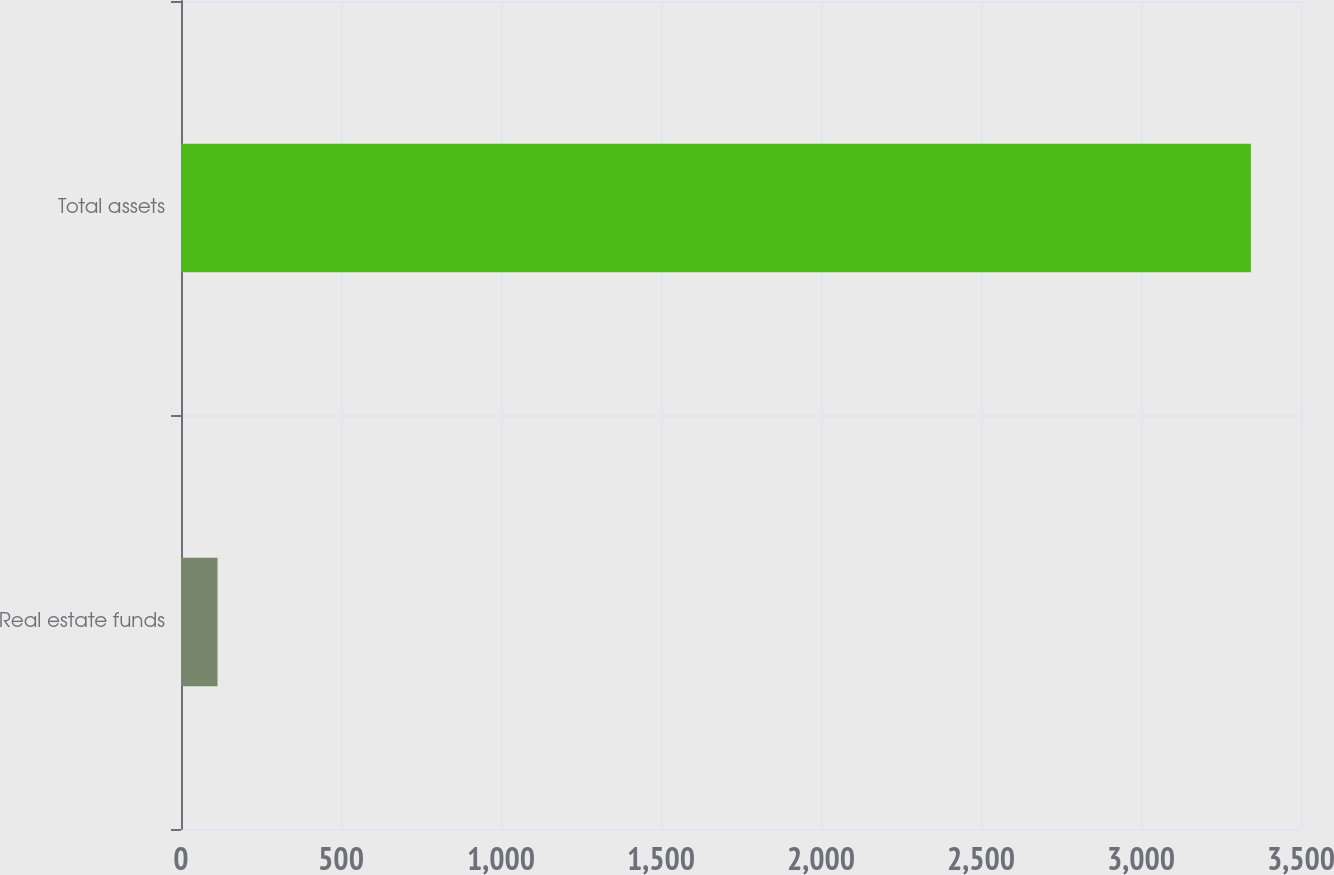Convert chart. <chart><loc_0><loc_0><loc_500><loc_500><bar_chart><fcel>Real estate funds<fcel>Total assets<nl><fcel>114.1<fcel>3343.3<nl></chart> 